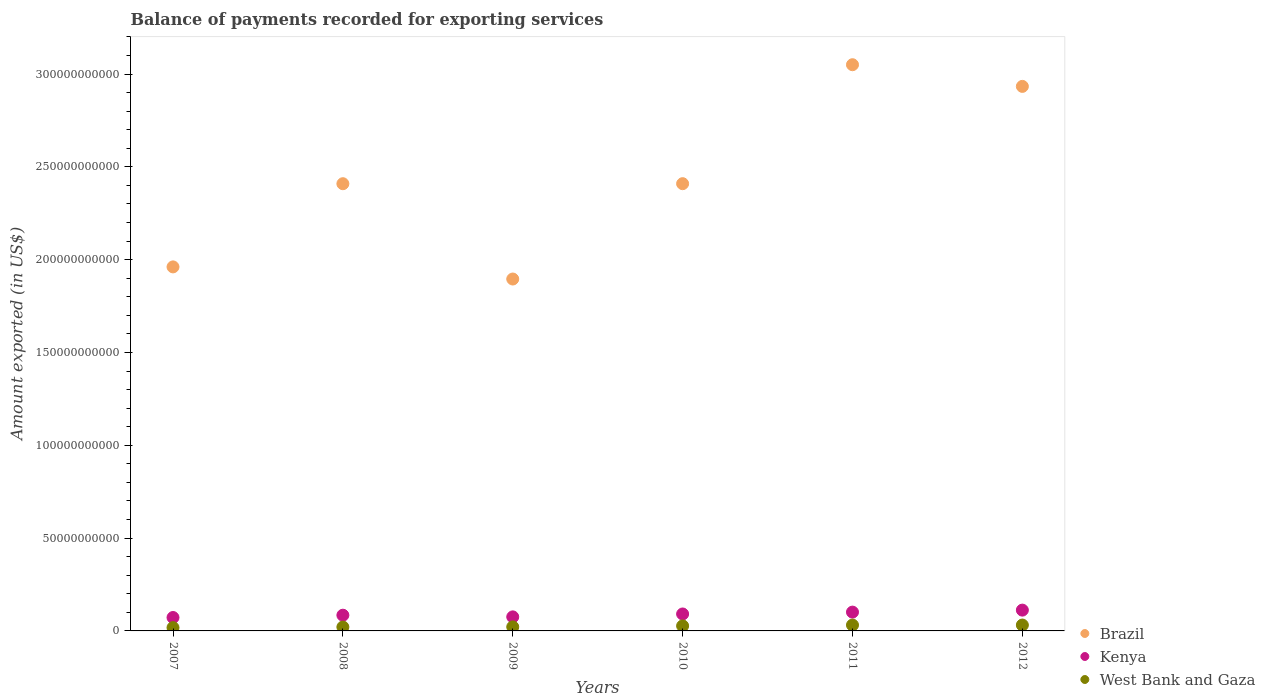Is the number of dotlines equal to the number of legend labels?
Offer a terse response. Yes. What is the amount exported in Kenya in 2007?
Offer a terse response. 7.22e+09. Across all years, what is the maximum amount exported in Kenya?
Offer a terse response. 1.12e+1. Across all years, what is the minimum amount exported in West Bank and Gaza?
Your response must be concise. 1.77e+09. In which year was the amount exported in West Bank and Gaza minimum?
Your answer should be compact. 2007. What is the total amount exported in Brazil in the graph?
Ensure brevity in your answer.  1.47e+12. What is the difference between the amount exported in Kenya in 2007 and that in 2009?
Provide a succinct answer. -3.44e+08. What is the difference between the amount exported in Kenya in 2008 and the amount exported in Brazil in 2009?
Ensure brevity in your answer.  -1.81e+11. What is the average amount exported in West Bank and Gaza per year?
Offer a terse response. 2.51e+09. In the year 2012, what is the difference between the amount exported in Kenya and amount exported in Brazil?
Offer a very short reply. -2.82e+11. What is the ratio of the amount exported in Brazil in 2008 to that in 2012?
Keep it short and to the point. 0.82. Is the amount exported in Kenya in 2007 less than that in 2012?
Your answer should be compact. Yes. What is the difference between the highest and the second highest amount exported in Kenya?
Provide a succinct answer. 1.08e+09. What is the difference between the highest and the lowest amount exported in Brazil?
Your answer should be very brief. 1.15e+11. Is the sum of the amount exported in Brazil in 2009 and 2011 greater than the maximum amount exported in Kenya across all years?
Your answer should be very brief. Yes. Is it the case that in every year, the sum of the amount exported in West Bank and Gaza and amount exported in Brazil  is greater than the amount exported in Kenya?
Provide a succinct answer. Yes. Does the amount exported in West Bank and Gaza monotonically increase over the years?
Your answer should be compact. No. Is the amount exported in Kenya strictly less than the amount exported in West Bank and Gaza over the years?
Your answer should be very brief. No. How many dotlines are there?
Make the answer very short. 3. Are the values on the major ticks of Y-axis written in scientific E-notation?
Ensure brevity in your answer.  No. Does the graph contain any zero values?
Keep it short and to the point. No. Does the graph contain grids?
Give a very brief answer. No. Where does the legend appear in the graph?
Provide a succinct answer. Bottom right. What is the title of the graph?
Give a very brief answer. Balance of payments recorded for exporting services. What is the label or title of the Y-axis?
Ensure brevity in your answer.  Amount exported (in US$). What is the Amount exported (in US$) of Brazil in 2007?
Your answer should be compact. 1.96e+11. What is the Amount exported (in US$) in Kenya in 2007?
Provide a short and direct response. 7.22e+09. What is the Amount exported (in US$) in West Bank and Gaza in 2007?
Ensure brevity in your answer.  1.77e+09. What is the Amount exported (in US$) of Brazil in 2008?
Your answer should be compact. 2.41e+11. What is the Amount exported (in US$) of Kenya in 2008?
Ensure brevity in your answer.  8.47e+09. What is the Amount exported (in US$) of West Bank and Gaza in 2008?
Make the answer very short. 2.09e+09. What is the Amount exported (in US$) of Brazil in 2009?
Ensure brevity in your answer.  1.90e+11. What is the Amount exported (in US$) in Kenya in 2009?
Your answer should be compact. 7.57e+09. What is the Amount exported (in US$) of West Bank and Gaza in 2009?
Make the answer very short. 2.17e+09. What is the Amount exported (in US$) in Brazil in 2010?
Keep it short and to the point. 2.41e+11. What is the Amount exported (in US$) of Kenya in 2010?
Ensure brevity in your answer.  9.13e+09. What is the Amount exported (in US$) in West Bank and Gaza in 2010?
Make the answer very short. 2.71e+09. What is the Amount exported (in US$) in Brazil in 2011?
Your answer should be very brief. 3.05e+11. What is the Amount exported (in US$) of Kenya in 2011?
Offer a terse response. 1.01e+1. What is the Amount exported (in US$) in West Bank and Gaza in 2011?
Your response must be concise. 3.16e+09. What is the Amount exported (in US$) in Brazil in 2012?
Make the answer very short. 2.93e+11. What is the Amount exported (in US$) in Kenya in 2012?
Provide a short and direct response. 1.12e+1. What is the Amount exported (in US$) of West Bank and Gaza in 2012?
Your answer should be very brief. 3.16e+09. Across all years, what is the maximum Amount exported (in US$) in Brazil?
Offer a terse response. 3.05e+11. Across all years, what is the maximum Amount exported (in US$) of Kenya?
Your response must be concise. 1.12e+1. Across all years, what is the maximum Amount exported (in US$) in West Bank and Gaza?
Provide a short and direct response. 3.16e+09. Across all years, what is the minimum Amount exported (in US$) of Brazil?
Your answer should be very brief. 1.90e+11. Across all years, what is the minimum Amount exported (in US$) of Kenya?
Provide a succinct answer. 7.22e+09. Across all years, what is the minimum Amount exported (in US$) of West Bank and Gaza?
Ensure brevity in your answer.  1.77e+09. What is the total Amount exported (in US$) in Brazil in the graph?
Ensure brevity in your answer.  1.47e+12. What is the total Amount exported (in US$) of Kenya in the graph?
Keep it short and to the point. 5.37e+1. What is the total Amount exported (in US$) in West Bank and Gaza in the graph?
Give a very brief answer. 1.51e+1. What is the difference between the Amount exported (in US$) of Brazil in 2007 and that in 2008?
Your response must be concise. -4.48e+1. What is the difference between the Amount exported (in US$) of Kenya in 2007 and that in 2008?
Your response must be concise. -1.24e+09. What is the difference between the Amount exported (in US$) in West Bank and Gaza in 2007 and that in 2008?
Make the answer very short. -3.21e+08. What is the difference between the Amount exported (in US$) in Brazil in 2007 and that in 2009?
Give a very brief answer. 6.53e+09. What is the difference between the Amount exported (in US$) in Kenya in 2007 and that in 2009?
Make the answer very short. -3.44e+08. What is the difference between the Amount exported (in US$) of West Bank and Gaza in 2007 and that in 2009?
Offer a very short reply. -4.00e+08. What is the difference between the Amount exported (in US$) in Brazil in 2007 and that in 2010?
Your answer should be very brief. -4.48e+1. What is the difference between the Amount exported (in US$) of Kenya in 2007 and that in 2010?
Ensure brevity in your answer.  -1.90e+09. What is the difference between the Amount exported (in US$) of West Bank and Gaza in 2007 and that in 2010?
Keep it short and to the point. -9.44e+08. What is the difference between the Amount exported (in US$) in Brazil in 2007 and that in 2011?
Provide a short and direct response. -1.09e+11. What is the difference between the Amount exported (in US$) of Kenya in 2007 and that in 2011?
Provide a short and direct response. -2.91e+09. What is the difference between the Amount exported (in US$) of West Bank and Gaza in 2007 and that in 2011?
Ensure brevity in your answer.  -1.39e+09. What is the difference between the Amount exported (in US$) of Brazil in 2007 and that in 2012?
Offer a terse response. -9.72e+1. What is the difference between the Amount exported (in US$) in Kenya in 2007 and that in 2012?
Offer a terse response. -3.98e+09. What is the difference between the Amount exported (in US$) of West Bank and Gaza in 2007 and that in 2012?
Your response must be concise. -1.39e+09. What is the difference between the Amount exported (in US$) of Brazil in 2008 and that in 2009?
Your answer should be compact. 5.13e+1. What is the difference between the Amount exported (in US$) of Kenya in 2008 and that in 2009?
Give a very brief answer. 9.00e+08. What is the difference between the Amount exported (in US$) of West Bank and Gaza in 2008 and that in 2009?
Your answer should be very brief. -7.94e+07. What is the difference between the Amount exported (in US$) of Brazil in 2008 and that in 2010?
Your answer should be compact. -1.56e+07. What is the difference between the Amount exported (in US$) of Kenya in 2008 and that in 2010?
Offer a very short reply. -6.61e+08. What is the difference between the Amount exported (in US$) of West Bank and Gaza in 2008 and that in 2010?
Provide a succinct answer. -6.23e+08. What is the difference between the Amount exported (in US$) of Brazil in 2008 and that in 2011?
Offer a very short reply. -6.41e+1. What is the difference between the Amount exported (in US$) in Kenya in 2008 and that in 2011?
Provide a succinct answer. -1.66e+09. What is the difference between the Amount exported (in US$) of West Bank and Gaza in 2008 and that in 2011?
Provide a short and direct response. -1.07e+09. What is the difference between the Amount exported (in US$) of Brazil in 2008 and that in 2012?
Give a very brief answer. -5.24e+1. What is the difference between the Amount exported (in US$) in Kenya in 2008 and that in 2012?
Keep it short and to the point. -2.74e+09. What is the difference between the Amount exported (in US$) of West Bank and Gaza in 2008 and that in 2012?
Offer a terse response. -1.07e+09. What is the difference between the Amount exported (in US$) in Brazil in 2009 and that in 2010?
Ensure brevity in your answer.  -5.14e+1. What is the difference between the Amount exported (in US$) of Kenya in 2009 and that in 2010?
Offer a terse response. -1.56e+09. What is the difference between the Amount exported (in US$) in West Bank and Gaza in 2009 and that in 2010?
Give a very brief answer. -5.44e+08. What is the difference between the Amount exported (in US$) in Brazil in 2009 and that in 2011?
Make the answer very short. -1.15e+11. What is the difference between the Amount exported (in US$) of Kenya in 2009 and that in 2011?
Provide a short and direct response. -2.56e+09. What is the difference between the Amount exported (in US$) in West Bank and Gaza in 2009 and that in 2011?
Your answer should be compact. -9.94e+08. What is the difference between the Amount exported (in US$) of Brazil in 2009 and that in 2012?
Make the answer very short. -1.04e+11. What is the difference between the Amount exported (in US$) of Kenya in 2009 and that in 2012?
Give a very brief answer. -3.64e+09. What is the difference between the Amount exported (in US$) in West Bank and Gaza in 2009 and that in 2012?
Give a very brief answer. -9.93e+08. What is the difference between the Amount exported (in US$) in Brazil in 2010 and that in 2011?
Ensure brevity in your answer.  -6.41e+1. What is the difference between the Amount exported (in US$) of Kenya in 2010 and that in 2011?
Your answer should be very brief. -1.00e+09. What is the difference between the Amount exported (in US$) of West Bank and Gaza in 2010 and that in 2011?
Your answer should be compact. -4.51e+08. What is the difference between the Amount exported (in US$) in Brazil in 2010 and that in 2012?
Make the answer very short. -5.24e+1. What is the difference between the Amount exported (in US$) of Kenya in 2010 and that in 2012?
Your answer should be very brief. -2.08e+09. What is the difference between the Amount exported (in US$) in West Bank and Gaza in 2010 and that in 2012?
Keep it short and to the point. -4.50e+08. What is the difference between the Amount exported (in US$) of Brazil in 2011 and that in 2012?
Your answer should be compact. 1.17e+1. What is the difference between the Amount exported (in US$) in Kenya in 2011 and that in 2012?
Provide a succinct answer. -1.08e+09. What is the difference between the Amount exported (in US$) in West Bank and Gaza in 2011 and that in 2012?
Offer a terse response. 9.34e+05. What is the difference between the Amount exported (in US$) of Brazil in 2007 and the Amount exported (in US$) of Kenya in 2008?
Offer a terse response. 1.88e+11. What is the difference between the Amount exported (in US$) in Brazil in 2007 and the Amount exported (in US$) in West Bank and Gaza in 2008?
Make the answer very short. 1.94e+11. What is the difference between the Amount exported (in US$) in Kenya in 2007 and the Amount exported (in US$) in West Bank and Gaza in 2008?
Your response must be concise. 5.14e+09. What is the difference between the Amount exported (in US$) in Brazil in 2007 and the Amount exported (in US$) in Kenya in 2009?
Provide a short and direct response. 1.89e+11. What is the difference between the Amount exported (in US$) of Brazil in 2007 and the Amount exported (in US$) of West Bank and Gaza in 2009?
Keep it short and to the point. 1.94e+11. What is the difference between the Amount exported (in US$) in Kenya in 2007 and the Amount exported (in US$) in West Bank and Gaza in 2009?
Provide a succinct answer. 5.06e+09. What is the difference between the Amount exported (in US$) of Brazil in 2007 and the Amount exported (in US$) of Kenya in 2010?
Make the answer very short. 1.87e+11. What is the difference between the Amount exported (in US$) of Brazil in 2007 and the Amount exported (in US$) of West Bank and Gaza in 2010?
Your response must be concise. 1.93e+11. What is the difference between the Amount exported (in US$) in Kenya in 2007 and the Amount exported (in US$) in West Bank and Gaza in 2010?
Keep it short and to the point. 4.51e+09. What is the difference between the Amount exported (in US$) of Brazil in 2007 and the Amount exported (in US$) of Kenya in 2011?
Offer a terse response. 1.86e+11. What is the difference between the Amount exported (in US$) of Brazil in 2007 and the Amount exported (in US$) of West Bank and Gaza in 2011?
Give a very brief answer. 1.93e+11. What is the difference between the Amount exported (in US$) of Kenya in 2007 and the Amount exported (in US$) of West Bank and Gaza in 2011?
Your answer should be very brief. 4.06e+09. What is the difference between the Amount exported (in US$) in Brazil in 2007 and the Amount exported (in US$) in Kenya in 2012?
Your answer should be compact. 1.85e+11. What is the difference between the Amount exported (in US$) of Brazil in 2007 and the Amount exported (in US$) of West Bank and Gaza in 2012?
Give a very brief answer. 1.93e+11. What is the difference between the Amount exported (in US$) of Kenya in 2007 and the Amount exported (in US$) of West Bank and Gaza in 2012?
Provide a succinct answer. 4.06e+09. What is the difference between the Amount exported (in US$) of Brazil in 2008 and the Amount exported (in US$) of Kenya in 2009?
Give a very brief answer. 2.33e+11. What is the difference between the Amount exported (in US$) in Brazil in 2008 and the Amount exported (in US$) in West Bank and Gaza in 2009?
Offer a very short reply. 2.39e+11. What is the difference between the Amount exported (in US$) in Kenya in 2008 and the Amount exported (in US$) in West Bank and Gaza in 2009?
Keep it short and to the point. 6.30e+09. What is the difference between the Amount exported (in US$) in Brazil in 2008 and the Amount exported (in US$) in Kenya in 2010?
Offer a terse response. 2.32e+11. What is the difference between the Amount exported (in US$) in Brazil in 2008 and the Amount exported (in US$) in West Bank and Gaza in 2010?
Offer a very short reply. 2.38e+11. What is the difference between the Amount exported (in US$) of Kenya in 2008 and the Amount exported (in US$) of West Bank and Gaza in 2010?
Your response must be concise. 5.76e+09. What is the difference between the Amount exported (in US$) in Brazil in 2008 and the Amount exported (in US$) in Kenya in 2011?
Your answer should be very brief. 2.31e+11. What is the difference between the Amount exported (in US$) in Brazil in 2008 and the Amount exported (in US$) in West Bank and Gaza in 2011?
Your response must be concise. 2.38e+11. What is the difference between the Amount exported (in US$) of Kenya in 2008 and the Amount exported (in US$) of West Bank and Gaza in 2011?
Provide a short and direct response. 5.31e+09. What is the difference between the Amount exported (in US$) of Brazil in 2008 and the Amount exported (in US$) of Kenya in 2012?
Give a very brief answer. 2.30e+11. What is the difference between the Amount exported (in US$) in Brazil in 2008 and the Amount exported (in US$) in West Bank and Gaza in 2012?
Provide a succinct answer. 2.38e+11. What is the difference between the Amount exported (in US$) in Kenya in 2008 and the Amount exported (in US$) in West Bank and Gaza in 2012?
Keep it short and to the point. 5.31e+09. What is the difference between the Amount exported (in US$) in Brazil in 2009 and the Amount exported (in US$) in Kenya in 2010?
Your answer should be compact. 1.80e+11. What is the difference between the Amount exported (in US$) in Brazil in 2009 and the Amount exported (in US$) in West Bank and Gaza in 2010?
Your answer should be very brief. 1.87e+11. What is the difference between the Amount exported (in US$) of Kenya in 2009 and the Amount exported (in US$) of West Bank and Gaza in 2010?
Keep it short and to the point. 4.86e+09. What is the difference between the Amount exported (in US$) of Brazil in 2009 and the Amount exported (in US$) of Kenya in 2011?
Provide a short and direct response. 1.79e+11. What is the difference between the Amount exported (in US$) in Brazil in 2009 and the Amount exported (in US$) in West Bank and Gaza in 2011?
Provide a short and direct response. 1.86e+11. What is the difference between the Amount exported (in US$) in Kenya in 2009 and the Amount exported (in US$) in West Bank and Gaza in 2011?
Ensure brevity in your answer.  4.41e+09. What is the difference between the Amount exported (in US$) of Brazil in 2009 and the Amount exported (in US$) of Kenya in 2012?
Your answer should be very brief. 1.78e+11. What is the difference between the Amount exported (in US$) in Brazil in 2009 and the Amount exported (in US$) in West Bank and Gaza in 2012?
Give a very brief answer. 1.86e+11. What is the difference between the Amount exported (in US$) in Kenya in 2009 and the Amount exported (in US$) in West Bank and Gaza in 2012?
Keep it short and to the point. 4.41e+09. What is the difference between the Amount exported (in US$) of Brazil in 2010 and the Amount exported (in US$) of Kenya in 2011?
Make the answer very short. 2.31e+11. What is the difference between the Amount exported (in US$) of Brazil in 2010 and the Amount exported (in US$) of West Bank and Gaza in 2011?
Give a very brief answer. 2.38e+11. What is the difference between the Amount exported (in US$) in Kenya in 2010 and the Amount exported (in US$) in West Bank and Gaza in 2011?
Your answer should be compact. 5.97e+09. What is the difference between the Amount exported (in US$) in Brazil in 2010 and the Amount exported (in US$) in Kenya in 2012?
Your answer should be compact. 2.30e+11. What is the difference between the Amount exported (in US$) in Brazil in 2010 and the Amount exported (in US$) in West Bank and Gaza in 2012?
Give a very brief answer. 2.38e+11. What is the difference between the Amount exported (in US$) in Kenya in 2010 and the Amount exported (in US$) in West Bank and Gaza in 2012?
Provide a succinct answer. 5.97e+09. What is the difference between the Amount exported (in US$) in Brazil in 2011 and the Amount exported (in US$) in Kenya in 2012?
Offer a very short reply. 2.94e+11. What is the difference between the Amount exported (in US$) in Brazil in 2011 and the Amount exported (in US$) in West Bank and Gaza in 2012?
Provide a succinct answer. 3.02e+11. What is the difference between the Amount exported (in US$) of Kenya in 2011 and the Amount exported (in US$) of West Bank and Gaza in 2012?
Provide a short and direct response. 6.97e+09. What is the average Amount exported (in US$) in Brazil per year?
Keep it short and to the point. 2.44e+11. What is the average Amount exported (in US$) of Kenya per year?
Make the answer very short. 8.95e+09. What is the average Amount exported (in US$) in West Bank and Gaza per year?
Your response must be concise. 2.51e+09. In the year 2007, what is the difference between the Amount exported (in US$) in Brazil and Amount exported (in US$) in Kenya?
Your answer should be compact. 1.89e+11. In the year 2007, what is the difference between the Amount exported (in US$) of Brazil and Amount exported (in US$) of West Bank and Gaza?
Offer a terse response. 1.94e+11. In the year 2007, what is the difference between the Amount exported (in US$) of Kenya and Amount exported (in US$) of West Bank and Gaza?
Keep it short and to the point. 5.46e+09. In the year 2008, what is the difference between the Amount exported (in US$) of Brazil and Amount exported (in US$) of Kenya?
Your answer should be very brief. 2.32e+11. In the year 2008, what is the difference between the Amount exported (in US$) of Brazil and Amount exported (in US$) of West Bank and Gaza?
Keep it short and to the point. 2.39e+11. In the year 2008, what is the difference between the Amount exported (in US$) in Kenya and Amount exported (in US$) in West Bank and Gaza?
Keep it short and to the point. 6.38e+09. In the year 2009, what is the difference between the Amount exported (in US$) of Brazil and Amount exported (in US$) of Kenya?
Make the answer very short. 1.82e+11. In the year 2009, what is the difference between the Amount exported (in US$) of Brazil and Amount exported (in US$) of West Bank and Gaza?
Offer a very short reply. 1.87e+11. In the year 2009, what is the difference between the Amount exported (in US$) in Kenya and Amount exported (in US$) in West Bank and Gaza?
Your answer should be very brief. 5.40e+09. In the year 2010, what is the difference between the Amount exported (in US$) in Brazil and Amount exported (in US$) in Kenya?
Make the answer very short. 2.32e+11. In the year 2010, what is the difference between the Amount exported (in US$) in Brazil and Amount exported (in US$) in West Bank and Gaza?
Provide a short and direct response. 2.38e+11. In the year 2010, what is the difference between the Amount exported (in US$) of Kenya and Amount exported (in US$) of West Bank and Gaza?
Keep it short and to the point. 6.42e+09. In the year 2011, what is the difference between the Amount exported (in US$) of Brazil and Amount exported (in US$) of Kenya?
Make the answer very short. 2.95e+11. In the year 2011, what is the difference between the Amount exported (in US$) in Brazil and Amount exported (in US$) in West Bank and Gaza?
Offer a terse response. 3.02e+11. In the year 2011, what is the difference between the Amount exported (in US$) in Kenya and Amount exported (in US$) in West Bank and Gaza?
Provide a succinct answer. 6.97e+09. In the year 2012, what is the difference between the Amount exported (in US$) of Brazil and Amount exported (in US$) of Kenya?
Ensure brevity in your answer.  2.82e+11. In the year 2012, what is the difference between the Amount exported (in US$) in Brazil and Amount exported (in US$) in West Bank and Gaza?
Provide a short and direct response. 2.90e+11. In the year 2012, what is the difference between the Amount exported (in US$) in Kenya and Amount exported (in US$) in West Bank and Gaza?
Offer a very short reply. 8.05e+09. What is the ratio of the Amount exported (in US$) in Brazil in 2007 to that in 2008?
Offer a very short reply. 0.81. What is the ratio of the Amount exported (in US$) of Kenya in 2007 to that in 2008?
Provide a short and direct response. 0.85. What is the ratio of the Amount exported (in US$) in West Bank and Gaza in 2007 to that in 2008?
Your answer should be compact. 0.85. What is the ratio of the Amount exported (in US$) of Brazil in 2007 to that in 2009?
Your answer should be very brief. 1.03. What is the ratio of the Amount exported (in US$) of Kenya in 2007 to that in 2009?
Make the answer very short. 0.95. What is the ratio of the Amount exported (in US$) of West Bank and Gaza in 2007 to that in 2009?
Provide a succinct answer. 0.82. What is the ratio of the Amount exported (in US$) in Brazil in 2007 to that in 2010?
Ensure brevity in your answer.  0.81. What is the ratio of the Amount exported (in US$) in Kenya in 2007 to that in 2010?
Your response must be concise. 0.79. What is the ratio of the Amount exported (in US$) in West Bank and Gaza in 2007 to that in 2010?
Your response must be concise. 0.65. What is the ratio of the Amount exported (in US$) of Brazil in 2007 to that in 2011?
Offer a very short reply. 0.64. What is the ratio of the Amount exported (in US$) of Kenya in 2007 to that in 2011?
Your response must be concise. 0.71. What is the ratio of the Amount exported (in US$) of West Bank and Gaza in 2007 to that in 2011?
Provide a short and direct response. 0.56. What is the ratio of the Amount exported (in US$) of Brazil in 2007 to that in 2012?
Keep it short and to the point. 0.67. What is the ratio of the Amount exported (in US$) of Kenya in 2007 to that in 2012?
Your answer should be compact. 0.64. What is the ratio of the Amount exported (in US$) in West Bank and Gaza in 2007 to that in 2012?
Keep it short and to the point. 0.56. What is the ratio of the Amount exported (in US$) of Brazil in 2008 to that in 2009?
Make the answer very short. 1.27. What is the ratio of the Amount exported (in US$) of Kenya in 2008 to that in 2009?
Provide a short and direct response. 1.12. What is the ratio of the Amount exported (in US$) of West Bank and Gaza in 2008 to that in 2009?
Give a very brief answer. 0.96. What is the ratio of the Amount exported (in US$) in Brazil in 2008 to that in 2010?
Your answer should be very brief. 1. What is the ratio of the Amount exported (in US$) in Kenya in 2008 to that in 2010?
Your answer should be very brief. 0.93. What is the ratio of the Amount exported (in US$) in West Bank and Gaza in 2008 to that in 2010?
Your answer should be very brief. 0.77. What is the ratio of the Amount exported (in US$) of Brazil in 2008 to that in 2011?
Your answer should be very brief. 0.79. What is the ratio of the Amount exported (in US$) of Kenya in 2008 to that in 2011?
Provide a short and direct response. 0.84. What is the ratio of the Amount exported (in US$) in West Bank and Gaza in 2008 to that in 2011?
Ensure brevity in your answer.  0.66. What is the ratio of the Amount exported (in US$) in Brazil in 2008 to that in 2012?
Your response must be concise. 0.82. What is the ratio of the Amount exported (in US$) of Kenya in 2008 to that in 2012?
Ensure brevity in your answer.  0.76. What is the ratio of the Amount exported (in US$) of West Bank and Gaza in 2008 to that in 2012?
Offer a very short reply. 0.66. What is the ratio of the Amount exported (in US$) of Brazil in 2009 to that in 2010?
Ensure brevity in your answer.  0.79. What is the ratio of the Amount exported (in US$) in Kenya in 2009 to that in 2010?
Make the answer very short. 0.83. What is the ratio of the Amount exported (in US$) of West Bank and Gaza in 2009 to that in 2010?
Offer a very short reply. 0.8. What is the ratio of the Amount exported (in US$) in Brazil in 2009 to that in 2011?
Ensure brevity in your answer.  0.62. What is the ratio of the Amount exported (in US$) in Kenya in 2009 to that in 2011?
Your answer should be compact. 0.75. What is the ratio of the Amount exported (in US$) in West Bank and Gaza in 2009 to that in 2011?
Keep it short and to the point. 0.69. What is the ratio of the Amount exported (in US$) of Brazil in 2009 to that in 2012?
Keep it short and to the point. 0.65. What is the ratio of the Amount exported (in US$) in Kenya in 2009 to that in 2012?
Provide a succinct answer. 0.68. What is the ratio of the Amount exported (in US$) of West Bank and Gaza in 2009 to that in 2012?
Give a very brief answer. 0.69. What is the ratio of the Amount exported (in US$) in Brazil in 2010 to that in 2011?
Ensure brevity in your answer.  0.79. What is the ratio of the Amount exported (in US$) in Kenya in 2010 to that in 2011?
Offer a very short reply. 0.9. What is the ratio of the Amount exported (in US$) in West Bank and Gaza in 2010 to that in 2011?
Make the answer very short. 0.86. What is the ratio of the Amount exported (in US$) of Brazil in 2010 to that in 2012?
Provide a short and direct response. 0.82. What is the ratio of the Amount exported (in US$) of Kenya in 2010 to that in 2012?
Give a very brief answer. 0.81. What is the ratio of the Amount exported (in US$) of West Bank and Gaza in 2010 to that in 2012?
Offer a very short reply. 0.86. What is the ratio of the Amount exported (in US$) of Brazil in 2011 to that in 2012?
Your answer should be compact. 1.04. What is the ratio of the Amount exported (in US$) in Kenya in 2011 to that in 2012?
Your response must be concise. 0.9. What is the difference between the highest and the second highest Amount exported (in US$) of Brazil?
Keep it short and to the point. 1.17e+1. What is the difference between the highest and the second highest Amount exported (in US$) of Kenya?
Your response must be concise. 1.08e+09. What is the difference between the highest and the second highest Amount exported (in US$) of West Bank and Gaza?
Offer a very short reply. 9.34e+05. What is the difference between the highest and the lowest Amount exported (in US$) in Brazil?
Ensure brevity in your answer.  1.15e+11. What is the difference between the highest and the lowest Amount exported (in US$) of Kenya?
Your answer should be compact. 3.98e+09. What is the difference between the highest and the lowest Amount exported (in US$) in West Bank and Gaza?
Give a very brief answer. 1.39e+09. 